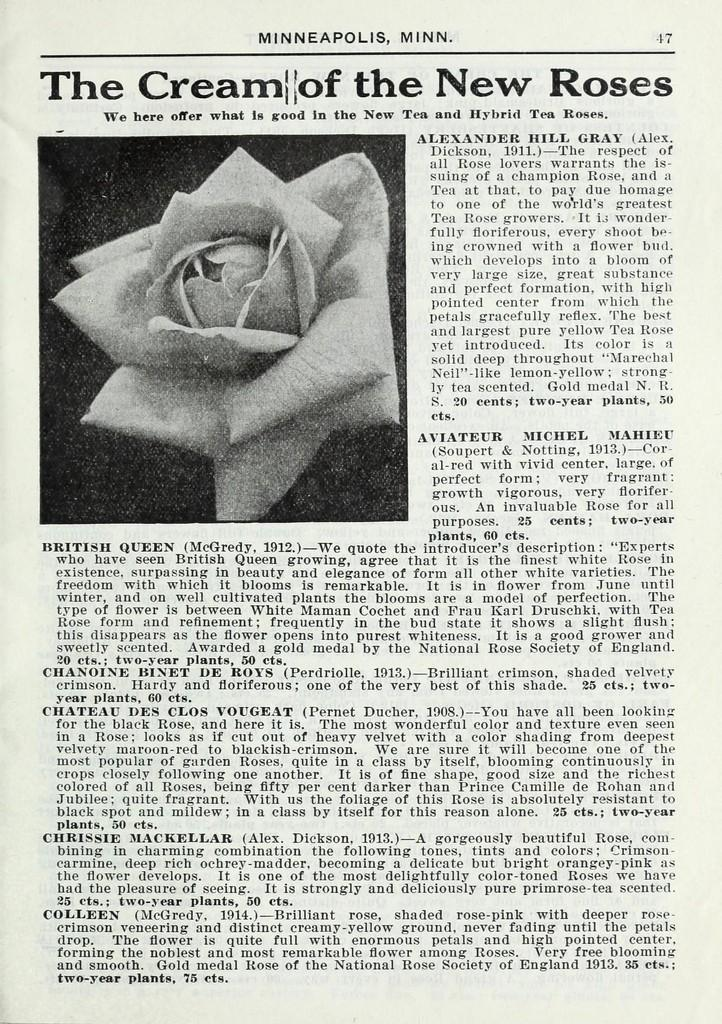What is the main subject of the image? There is an article in the image. Can you describe the article in the image? Unfortunately, the details of the article cannot be determined from the image alone. What type of insect can be seen crawling on the article in the image? There is no insect present in the image; it only features an article. 